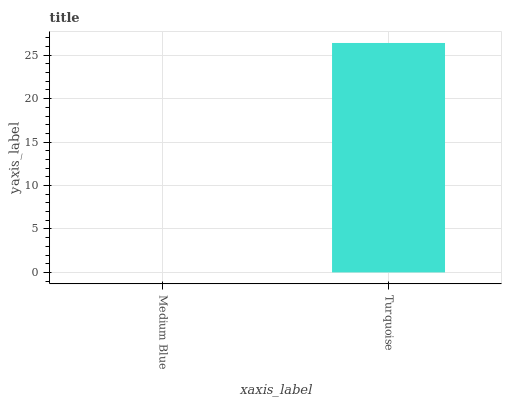Is Medium Blue the minimum?
Answer yes or no. Yes. Is Turquoise the maximum?
Answer yes or no. Yes. Is Turquoise the minimum?
Answer yes or no. No. Is Turquoise greater than Medium Blue?
Answer yes or no. Yes. Is Medium Blue less than Turquoise?
Answer yes or no. Yes. Is Medium Blue greater than Turquoise?
Answer yes or no. No. Is Turquoise less than Medium Blue?
Answer yes or no. No. Is Turquoise the high median?
Answer yes or no. Yes. Is Medium Blue the low median?
Answer yes or no. Yes. Is Medium Blue the high median?
Answer yes or no. No. Is Turquoise the low median?
Answer yes or no. No. 